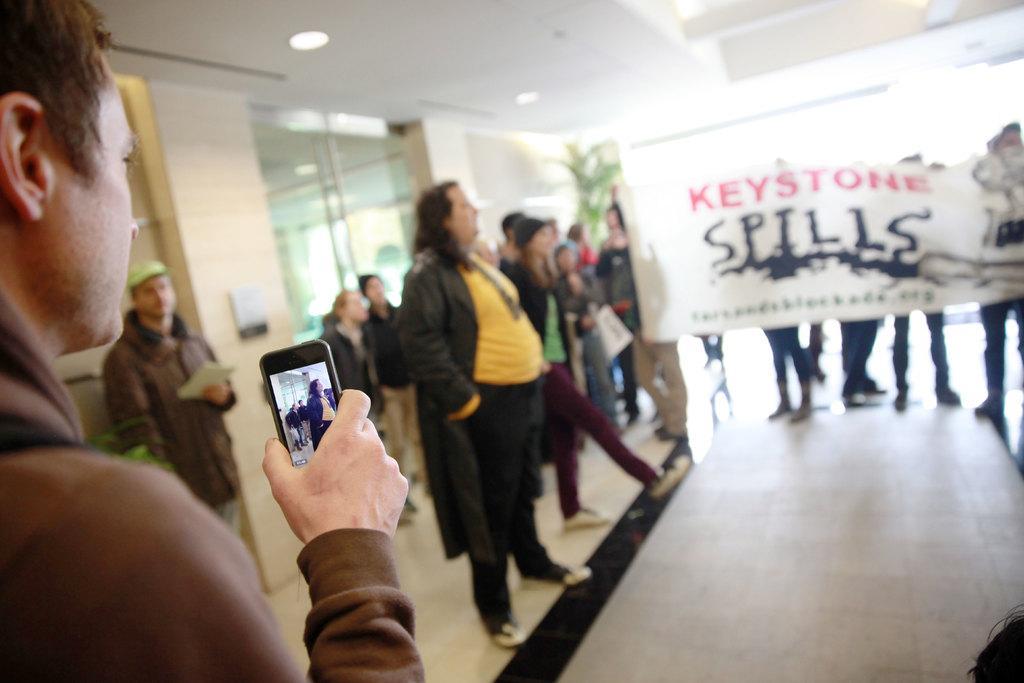Describe this image in one or two sentences. In this image we can see an inside of a building. There are many people in the image. There are few people holding a banner in their hands. A person is holding a mobile phone in his hand at the left side of the image. A person is holding a book in his hand at the left side of the image. There are few lights attached to the roof in the image. 